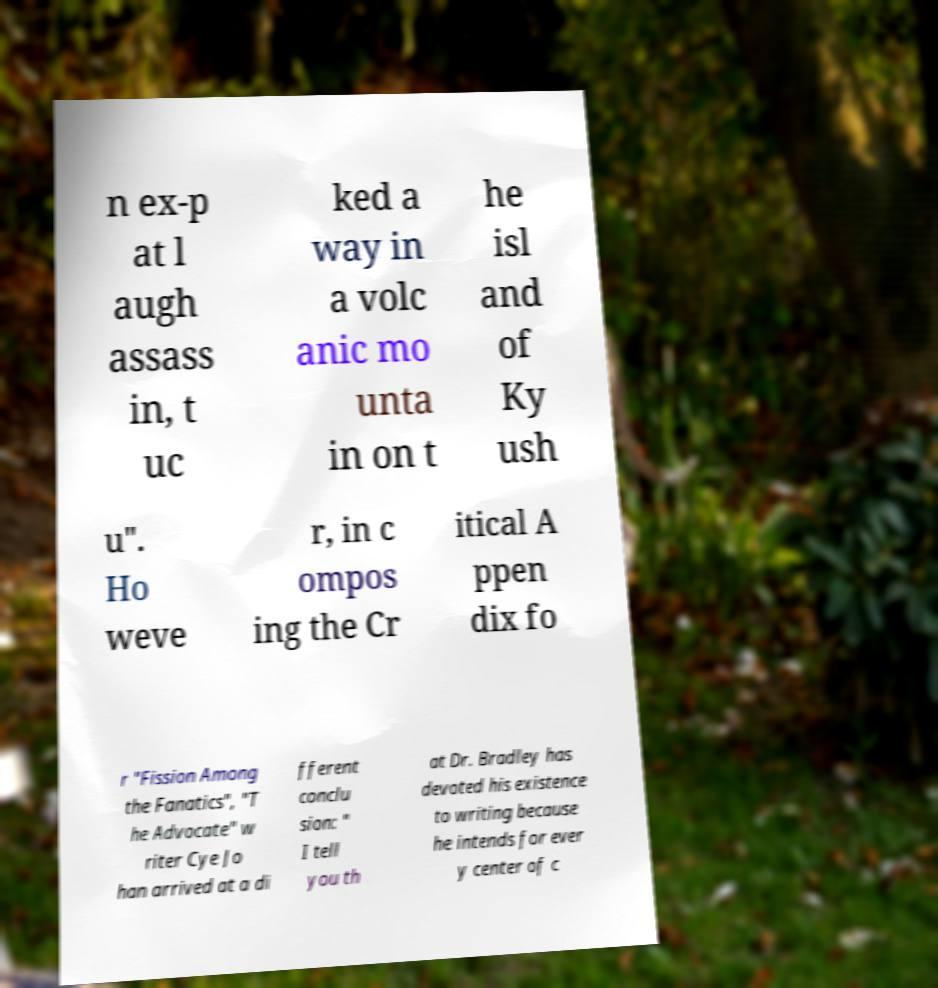I need the written content from this picture converted into text. Can you do that? n ex-p at l augh assass in, t uc ked a way in a volc anic mo unta in on t he isl and of Ky ush u". Ho weve r, in c ompos ing the Cr itical A ppen dix fo r "Fission Among the Fanatics", "T he Advocate" w riter Cye Jo han arrived at a di fferent conclu sion: " I tell you th at Dr. Bradley has devoted his existence to writing because he intends for ever y center of c 